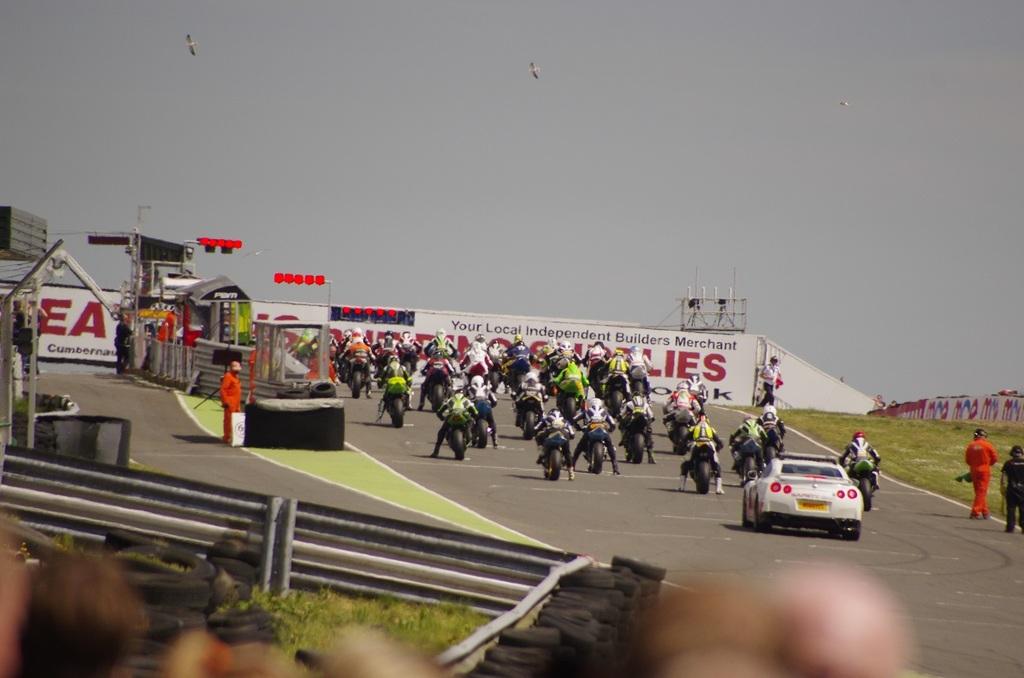What two letters are most visible on the left?
Ensure brevity in your answer.  Ea. 